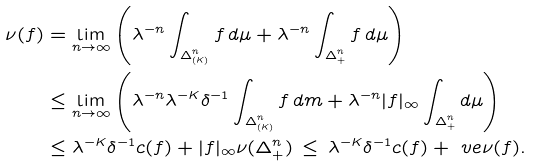<formula> <loc_0><loc_0><loc_500><loc_500>\nu ( f ) & = \lim _ { n \to \infty } \left ( \lambda ^ { - n } \int _ { \Delta ^ { n } _ { ( K ) } } f \, d \mu + \lambda ^ { - n } \int _ { \Delta ^ { n } _ { + } } f \, d \mu \right ) \\ & \leq \lim _ { n \to \infty } \left ( \lambda ^ { - n } \lambda ^ { - K } \delta ^ { - 1 } \int _ { \Delta ^ { n } _ { ( K ) } } f \, d m + \lambda ^ { - n } | f | _ { \infty } \int _ { \Delta ^ { n } _ { + } } d \mu \right ) \\ & \leq \lambda ^ { - K } \delta ^ { - 1 } c ( f ) + | f | _ { \infty } \nu ( \Delta ^ { n } _ { + } ) \, \leq \, \lambda ^ { - K } \delta ^ { - 1 } c ( f ) + \ v e \nu ( f ) .</formula> 